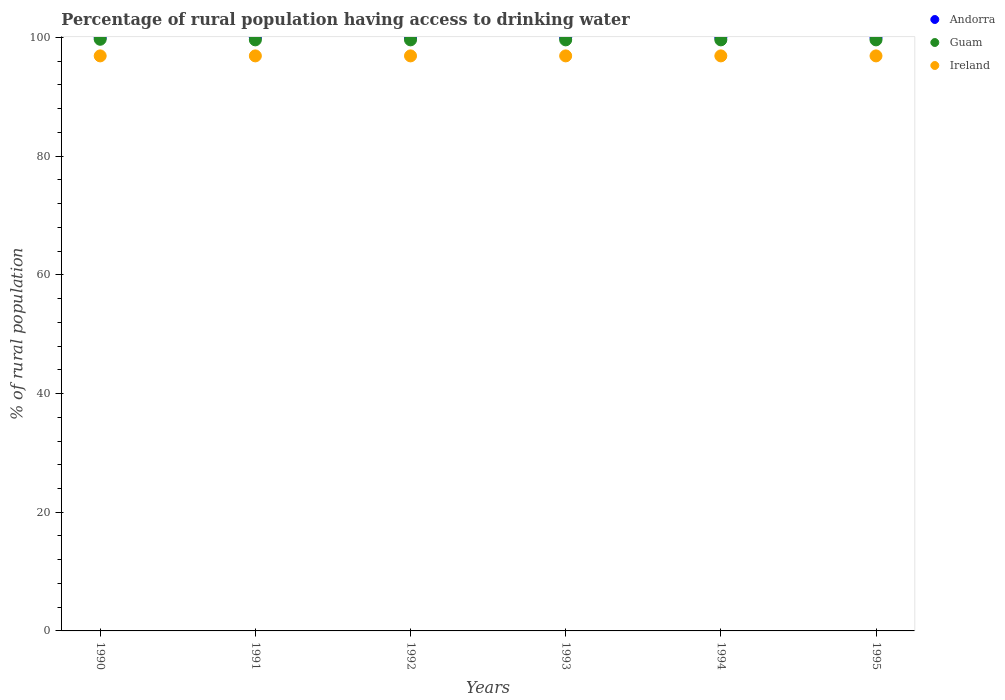How many different coloured dotlines are there?
Keep it short and to the point. 3. What is the percentage of rural population having access to drinking water in Andorra in 1992?
Your response must be concise. 100. Across all years, what is the maximum percentage of rural population having access to drinking water in Guam?
Offer a very short reply. 99.7. Across all years, what is the minimum percentage of rural population having access to drinking water in Andorra?
Keep it short and to the point. 100. In which year was the percentage of rural population having access to drinking water in Ireland minimum?
Give a very brief answer. 1990. What is the total percentage of rural population having access to drinking water in Ireland in the graph?
Your answer should be compact. 581.4. What is the difference between the percentage of rural population having access to drinking water in Ireland in 1993 and that in 1995?
Provide a short and direct response. 0. What is the difference between the percentage of rural population having access to drinking water in Ireland in 1991 and the percentage of rural population having access to drinking water in Guam in 1990?
Ensure brevity in your answer.  -2.8. What is the average percentage of rural population having access to drinking water in Ireland per year?
Provide a succinct answer. 96.9. In the year 1991, what is the difference between the percentage of rural population having access to drinking water in Guam and percentage of rural population having access to drinking water in Ireland?
Provide a succinct answer. 2.7. What is the ratio of the percentage of rural population having access to drinking water in Guam in 1990 to that in 1993?
Keep it short and to the point. 1. Is the percentage of rural population having access to drinking water in Ireland in 1990 less than that in 1993?
Offer a terse response. No. What is the difference between the highest and the second highest percentage of rural population having access to drinking water in Guam?
Your answer should be very brief. 0.1. In how many years, is the percentage of rural population having access to drinking water in Andorra greater than the average percentage of rural population having access to drinking water in Andorra taken over all years?
Provide a short and direct response. 0. Is the sum of the percentage of rural population having access to drinking water in Andorra in 1991 and 1992 greater than the maximum percentage of rural population having access to drinking water in Guam across all years?
Ensure brevity in your answer.  Yes. Is it the case that in every year, the sum of the percentage of rural population having access to drinking water in Ireland and percentage of rural population having access to drinking water in Andorra  is greater than the percentage of rural population having access to drinking water in Guam?
Offer a very short reply. Yes. Does the percentage of rural population having access to drinking water in Ireland monotonically increase over the years?
Your answer should be very brief. No. Is the percentage of rural population having access to drinking water in Andorra strictly less than the percentage of rural population having access to drinking water in Guam over the years?
Keep it short and to the point. No. How many dotlines are there?
Offer a terse response. 3. How many years are there in the graph?
Provide a short and direct response. 6. Are the values on the major ticks of Y-axis written in scientific E-notation?
Keep it short and to the point. No. Does the graph contain any zero values?
Ensure brevity in your answer.  No. Does the graph contain grids?
Give a very brief answer. No. Where does the legend appear in the graph?
Give a very brief answer. Top right. How many legend labels are there?
Make the answer very short. 3. What is the title of the graph?
Keep it short and to the point. Percentage of rural population having access to drinking water. Does "Puerto Rico" appear as one of the legend labels in the graph?
Your response must be concise. No. What is the label or title of the Y-axis?
Your answer should be compact. % of rural population. What is the % of rural population in Andorra in 1990?
Make the answer very short. 100. What is the % of rural population in Guam in 1990?
Offer a very short reply. 99.7. What is the % of rural population in Ireland in 1990?
Your answer should be compact. 96.9. What is the % of rural population in Guam in 1991?
Keep it short and to the point. 99.6. What is the % of rural population of Ireland in 1991?
Your answer should be compact. 96.9. What is the % of rural population in Andorra in 1992?
Your answer should be very brief. 100. What is the % of rural population in Guam in 1992?
Give a very brief answer. 99.6. What is the % of rural population in Ireland in 1992?
Provide a short and direct response. 96.9. What is the % of rural population of Andorra in 1993?
Provide a succinct answer. 100. What is the % of rural population in Guam in 1993?
Provide a short and direct response. 99.6. What is the % of rural population in Ireland in 1993?
Your answer should be very brief. 96.9. What is the % of rural population of Guam in 1994?
Your answer should be compact. 99.6. What is the % of rural population in Ireland in 1994?
Give a very brief answer. 96.9. What is the % of rural population of Guam in 1995?
Your answer should be compact. 99.6. What is the % of rural population of Ireland in 1995?
Offer a terse response. 96.9. Across all years, what is the maximum % of rural population of Guam?
Offer a very short reply. 99.7. Across all years, what is the maximum % of rural population of Ireland?
Your answer should be very brief. 96.9. Across all years, what is the minimum % of rural population in Andorra?
Make the answer very short. 100. Across all years, what is the minimum % of rural population of Guam?
Provide a succinct answer. 99.6. Across all years, what is the minimum % of rural population in Ireland?
Your response must be concise. 96.9. What is the total % of rural population in Andorra in the graph?
Offer a terse response. 600. What is the total % of rural population in Guam in the graph?
Offer a terse response. 597.7. What is the total % of rural population in Ireland in the graph?
Give a very brief answer. 581.4. What is the difference between the % of rural population in Andorra in 1990 and that in 1991?
Provide a succinct answer. 0. What is the difference between the % of rural population in Guam in 1990 and that in 1991?
Give a very brief answer. 0.1. What is the difference between the % of rural population of Andorra in 1990 and that in 1992?
Provide a short and direct response. 0. What is the difference between the % of rural population in Andorra in 1990 and that in 1993?
Your answer should be compact. 0. What is the difference between the % of rural population in Andorra in 1990 and that in 1994?
Your response must be concise. 0. What is the difference between the % of rural population in Guam in 1990 and that in 1994?
Offer a very short reply. 0.1. What is the difference between the % of rural population of Andorra in 1990 and that in 1995?
Keep it short and to the point. 0. What is the difference between the % of rural population in Andorra in 1991 and that in 1992?
Ensure brevity in your answer.  0. What is the difference between the % of rural population of Andorra in 1991 and that in 1993?
Offer a terse response. 0. What is the difference between the % of rural population in Guam in 1991 and that in 1993?
Your answer should be compact. 0. What is the difference between the % of rural population of Ireland in 1991 and that in 1994?
Offer a terse response. 0. What is the difference between the % of rural population of Guam in 1991 and that in 1995?
Keep it short and to the point. 0. What is the difference between the % of rural population in Andorra in 1992 and that in 1993?
Ensure brevity in your answer.  0. What is the difference between the % of rural population in Guam in 1992 and that in 1993?
Offer a terse response. 0. What is the difference between the % of rural population in Ireland in 1992 and that in 1993?
Your response must be concise. 0. What is the difference between the % of rural population of Andorra in 1992 and that in 1994?
Your answer should be very brief. 0. What is the difference between the % of rural population of Andorra in 1993 and that in 1994?
Provide a short and direct response. 0. What is the difference between the % of rural population in Guam in 1993 and that in 1994?
Ensure brevity in your answer.  0. What is the difference between the % of rural population in Ireland in 1993 and that in 1994?
Make the answer very short. 0. What is the difference between the % of rural population in Guam in 1994 and that in 1995?
Make the answer very short. 0. What is the difference between the % of rural population in Andorra in 1990 and the % of rural population in Ireland in 1991?
Keep it short and to the point. 3.1. What is the difference between the % of rural population in Andorra in 1990 and the % of rural population in Guam in 1994?
Offer a terse response. 0.4. What is the difference between the % of rural population of Guam in 1990 and the % of rural population of Ireland in 1994?
Your answer should be compact. 2.8. What is the difference between the % of rural population in Andorra in 1990 and the % of rural population in Guam in 1995?
Your answer should be compact. 0.4. What is the difference between the % of rural population in Andorra in 1990 and the % of rural population in Ireland in 1995?
Provide a succinct answer. 3.1. What is the difference between the % of rural population in Andorra in 1991 and the % of rural population in Guam in 1992?
Offer a very short reply. 0.4. What is the difference between the % of rural population of Guam in 1991 and the % of rural population of Ireland in 1992?
Your answer should be very brief. 2.7. What is the difference between the % of rural population of Andorra in 1991 and the % of rural population of Ireland in 1994?
Keep it short and to the point. 3.1. What is the difference between the % of rural population of Andorra in 1991 and the % of rural population of Guam in 1995?
Make the answer very short. 0.4. What is the difference between the % of rural population in Andorra in 1991 and the % of rural population in Ireland in 1995?
Your answer should be compact. 3.1. What is the difference between the % of rural population in Andorra in 1992 and the % of rural population in Ireland in 1993?
Give a very brief answer. 3.1. What is the difference between the % of rural population in Guam in 1992 and the % of rural population in Ireland in 1993?
Keep it short and to the point. 2.7. What is the difference between the % of rural population in Andorra in 1992 and the % of rural population in Ireland in 1994?
Offer a very short reply. 3.1. What is the difference between the % of rural population of Andorra in 1992 and the % of rural population of Guam in 1995?
Ensure brevity in your answer.  0.4. What is the difference between the % of rural population in Andorra in 1992 and the % of rural population in Ireland in 1995?
Give a very brief answer. 3.1. What is the difference between the % of rural population in Andorra in 1993 and the % of rural population in Ireland in 1994?
Give a very brief answer. 3.1. What is the difference between the % of rural population of Guam in 1993 and the % of rural population of Ireland in 1994?
Make the answer very short. 2.7. What is the difference between the % of rural population in Guam in 1993 and the % of rural population in Ireland in 1995?
Your answer should be compact. 2.7. What is the difference between the % of rural population in Andorra in 1994 and the % of rural population in Ireland in 1995?
Offer a terse response. 3.1. What is the average % of rural population of Guam per year?
Make the answer very short. 99.62. What is the average % of rural population in Ireland per year?
Your answer should be compact. 96.9. In the year 1990, what is the difference between the % of rural population of Andorra and % of rural population of Ireland?
Your answer should be very brief. 3.1. In the year 1991, what is the difference between the % of rural population in Andorra and % of rural population in Ireland?
Give a very brief answer. 3.1. In the year 1991, what is the difference between the % of rural population of Guam and % of rural population of Ireland?
Offer a very short reply. 2.7. In the year 1993, what is the difference between the % of rural population of Andorra and % of rural population of Ireland?
Provide a succinct answer. 3.1. In the year 1994, what is the difference between the % of rural population in Guam and % of rural population in Ireland?
Offer a terse response. 2.7. In the year 1995, what is the difference between the % of rural population in Andorra and % of rural population in Guam?
Your answer should be very brief. 0.4. What is the ratio of the % of rural population of Guam in 1990 to that in 1991?
Offer a terse response. 1. What is the ratio of the % of rural population of Ireland in 1990 to that in 1991?
Your answer should be very brief. 1. What is the ratio of the % of rural population of Guam in 1990 to that in 1992?
Keep it short and to the point. 1. What is the ratio of the % of rural population in Ireland in 1990 to that in 1992?
Your answer should be compact. 1. What is the ratio of the % of rural population in Guam in 1990 to that in 1993?
Make the answer very short. 1. What is the ratio of the % of rural population of Ireland in 1990 to that in 1993?
Provide a succinct answer. 1. What is the ratio of the % of rural population of Andorra in 1990 to that in 1995?
Your response must be concise. 1. What is the ratio of the % of rural population in Andorra in 1991 to that in 1992?
Offer a very short reply. 1. What is the ratio of the % of rural population in Guam in 1991 to that in 1993?
Offer a terse response. 1. What is the ratio of the % of rural population of Guam in 1991 to that in 1994?
Keep it short and to the point. 1. What is the ratio of the % of rural population of Guam in 1991 to that in 1995?
Offer a very short reply. 1. What is the ratio of the % of rural population of Guam in 1992 to that in 1993?
Your answer should be very brief. 1. What is the ratio of the % of rural population in Ireland in 1992 to that in 1993?
Your answer should be very brief. 1. What is the ratio of the % of rural population of Guam in 1992 to that in 1994?
Your response must be concise. 1. What is the ratio of the % of rural population in Andorra in 1992 to that in 1995?
Ensure brevity in your answer.  1. What is the ratio of the % of rural population in Guam in 1992 to that in 1995?
Keep it short and to the point. 1. What is the ratio of the % of rural population in Ireland in 1992 to that in 1995?
Offer a terse response. 1. What is the ratio of the % of rural population in Guam in 1993 to that in 1994?
Give a very brief answer. 1. What is the ratio of the % of rural population in Ireland in 1993 to that in 1994?
Your answer should be very brief. 1. What is the ratio of the % of rural population of Andorra in 1994 to that in 1995?
Offer a terse response. 1. What is the difference between the highest and the second highest % of rural population in Ireland?
Keep it short and to the point. 0. What is the difference between the highest and the lowest % of rural population of Guam?
Your answer should be compact. 0.1. What is the difference between the highest and the lowest % of rural population of Ireland?
Provide a short and direct response. 0. 